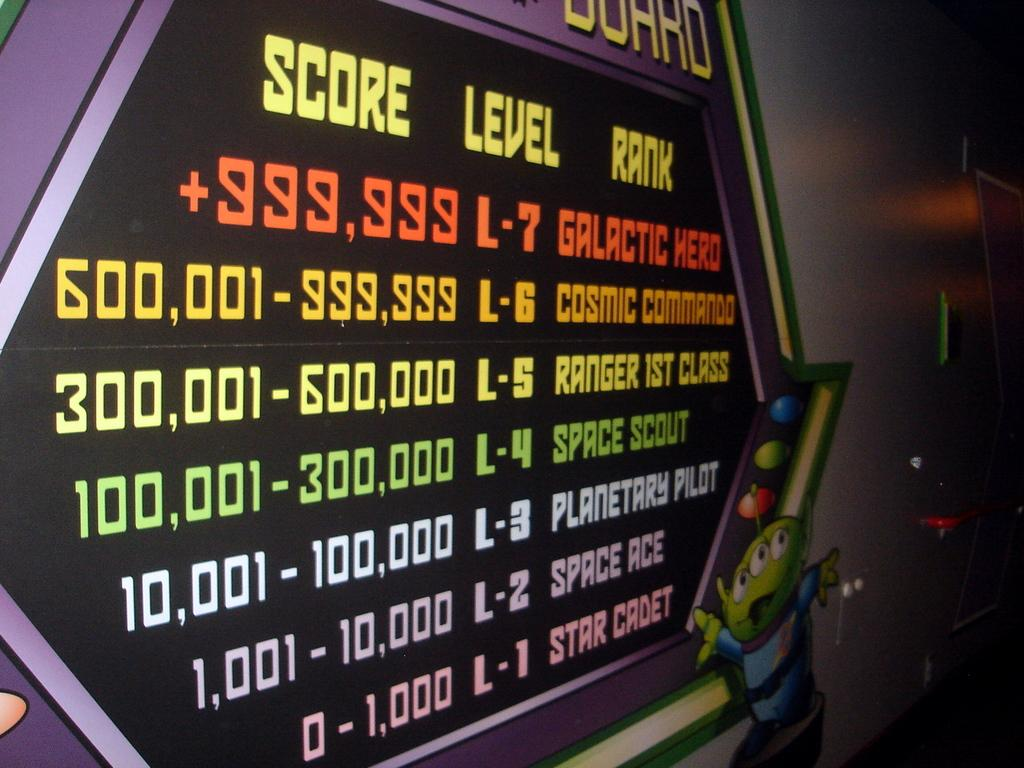What can be seen in the background of the image? There is a wall in the image. What is on the wall? There is writing on the wall. What else is on the wall besides the writing? There is an image of a cartoon character in the image. What type of lumber is being used to construct the wall in the image? There is no information about the construction of the wall or the type of lumber used in the image. 